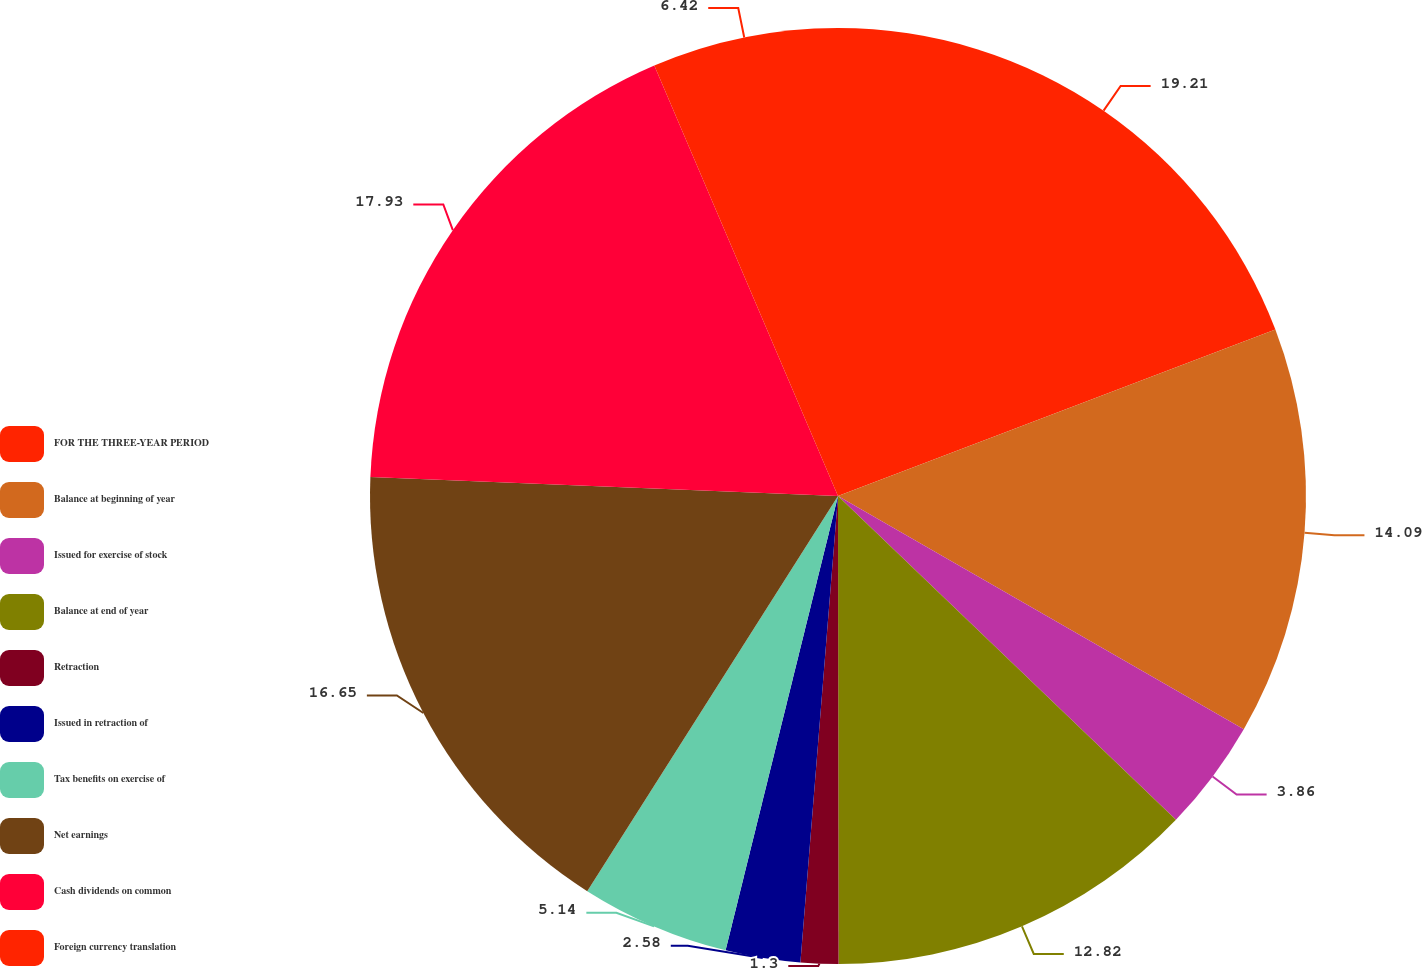Convert chart to OTSL. <chart><loc_0><loc_0><loc_500><loc_500><pie_chart><fcel>FOR THE THREE-YEAR PERIOD<fcel>Balance at beginning of year<fcel>Issued for exercise of stock<fcel>Balance at end of year<fcel>Retraction<fcel>Issued in retraction of<fcel>Tax benefits on exercise of<fcel>Net earnings<fcel>Cash dividends on common<fcel>Foreign currency translation<nl><fcel>19.21%<fcel>14.09%<fcel>3.86%<fcel>12.82%<fcel>1.3%<fcel>2.58%<fcel>5.14%<fcel>16.65%<fcel>17.93%<fcel>6.42%<nl></chart> 